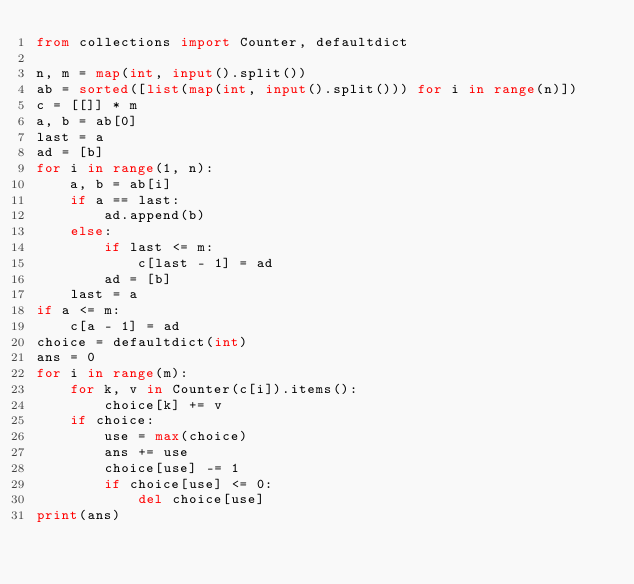Convert code to text. <code><loc_0><loc_0><loc_500><loc_500><_Python_>from collections import Counter, defaultdict

n, m = map(int, input().split())
ab = sorted([list(map(int, input().split())) for i in range(n)])
c = [[]] * m
a, b = ab[0]
last = a
ad = [b]
for i in range(1, n):
    a, b = ab[i]
    if a == last:
        ad.append(b)
    else:
        if last <= m:
            c[last - 1] = ad
        ad = [b]
    last = a
if a <= m:
    c[a - 1] = ad
choice = defaultdict(int)
ans = 0
for i in range(m):
    for k, v in Counter(c[i]).items():
        choice[k] += v
    if choice:
        use = max(choice)
        ans += use
        choice[use] -= 1
        if choice[use] <= 0:
            del choice[use]
print(ans)</code> 